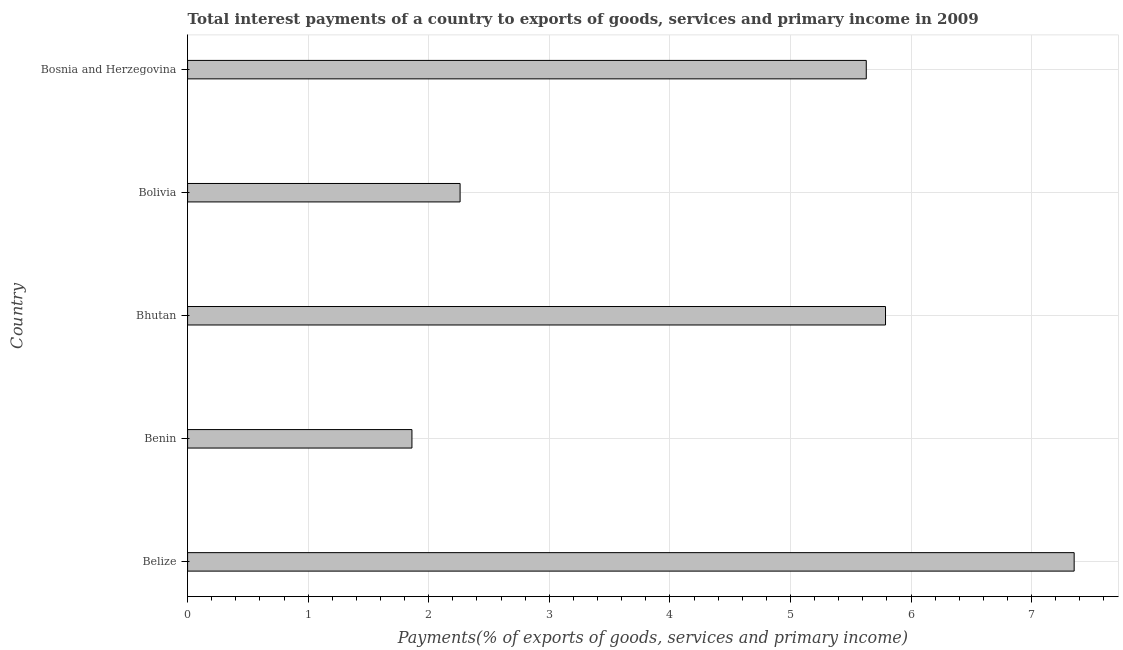Does the graph contain any zero values?
Your answer should be compact. No. Does the graph contain grids?
Give a very brief answer. Yes. What is the title of the graph?
Your answer should be very brief. Total interest payments of a country to exports of goods, services and primary income in 2009. What is the label or title of the X-axis?
Keep it short and to the point. Payments(% of exports of goods, services and primary income). What is the total interest payments on external debt in Bosnia and Herzegovina?
Offer a terse response. 5.63. Across all countries, what is the maximum total interest payments on external debt?
Make the answer very short. 7.35. Across all countries, what is the minimum total interest payments on external debt?
Provide a succinct answer. 1.86. In which country was the total interest payments on external debt maximum?
Your answer should be very brief. Belize. In which country was the total interest payments on external debt minimum?
Provide a succinct answer. Benin. What is the sum of the total interest payments on external debt?
Offer a terse response. 22.89. What is the difference between the total interest payments on external debt in Belize and Bolivia?
Ensure brevity in your answer.  5.09. What is the average total interest payments on external debt per country?
Give a very brief answer. 4.58. What is the median total interest payments on external debt?
Keep it short and to the point. 5.63. In how many countries, is the total interest payments on external debt greater than 6.6 %?
Provide a short and direct response. 1. What is the ratio of the total interest payments on external debt in Bolivia to that in Bosnia and Herzegovina?
Provide a short and direct response. 0.4. Is the total interest payments on external debt in Belize less than that in Bosnia and Herzegovina?
Provide a short and direct response. No. Is the difference between the total interest payments on external debt in Belize and Bolivia greater than the difference between any two countries?
Keep it short and to the point. No. What is the difference between the highest and the second highest total interest payments on external debt?
Provide a succinct answer. 1.56. What is the difference between the highest and the lowest total interest payments on external debt?
Provide a short and direct response. 5.49. How many countries are there in the graph?
Your answer should be very brief. 5. Are the values on the major ticks of X-axis written in scientific E-notation?
Give a very brief answer. No. What is the Payments(% of exports of goods, services and primary income) of Belize?
Your answer should be compact. 7.35. What is the Payments(% of exports of goods, services and primary income) of Benin?
Give a very brief answer. 1.86. What is the Payments(% of exports of goods, services and primary income) in Bhutan?
Keep it short and to the point. 5.79. What is the Payments(% of exports of goods, services and primary income) in Bolivia?
Your answer should be very brief. 2.26. What is the Payments(% of exports of goods, services and primary income) in Bosnia and Herzegovina?
Offer a very short reply. 5.63. What is the difference between the Payments(% of exports of goods, services and primary income) in Belize and Benin?
Provide a succinct answer. 5.49. What is the difference between the Payments(% of exports of goods, services and primary income) in Belize and Bhutan?
Offer a very short reply. 1.56. What is the difference between the Payments(% of exports of goods, services and primary income) in Belize and Bolivia?
Make the answer very short. 5.09. What is the difference between the Payments(% of exports of goods, services and primary income) in Belize and Bosnia and Herzegovina?
Give a very brief answer. 1.72. What is the difference between the Payments(% of exports of goods, services and primary income) in Benin and Bhutan?
Provide a succinct answer. -3.93. What is the difference between the Payments(% of exports of goods, services and primary income) in Benin and Bolivia?
Keep it short and to the point. -0.4. What is the difference between the Payments(% of exports of goods, services and primary income) in Benin and Bosnia and Herzegovina?
Offer a very short reply. -3.77. What is the difference between the Payments(% of exports of goods, services and primary income) in Bhutan and Bolivia?
Make the answer very short. 3.53. What is the difference between the Payments(% of exports of goods, services and primary income) in Bhutan and Bosnia and Herzegovina?
Ensure brevity in your answer.  0.16. What is the difference between the Payments(% of exports of goods, services and primary income) in Bolivia and Bosnia and Herzegovina?
Provide a short and direct response. -3.37. What is the ratio of the Payments(% of exports of goods, services and primary income) in Belize to that in Benin?
Offer a very short reply. 3.95. What is the ratio of the Payments(% of exports of goods, services and primary income) in Belize to that in Bhutan?
Keep it short and to the point. 1.27. What is the ratio of the Payments(% of exports of goods, services and primary income) in Belize to that in Bolivia?
Give a very brief answer. 3.25. What is the ratio of the Payments(% of exports of goods, services and primary income) in Belize to that in Bosnia and Herzegovina?
Give a very brief answer. 1.31. What is the ratio of the Payments(% of exports of goods, services and primary income) in Benin to that in Bhutan?
Your response must be concise. 0.32. What is the ratio of the Payments(% of exports of goods, services and primary income) in Benin to that in Bolivia?
Provide a succinct answer. 0.82. What is the ratio of the Payments(% of exports of goods, services and primary income) in Benin to that in Bosnia and Herzegovina?
Ensure brevity in your answer.  0.33. What is the ratio of the Payments(% of exports of goods, services and primary income) in Bhutan to that in Bolivia?
Your response must be concise. 2.56. What is the ratio of the Payments(% of exports of goods, services and primary income) in Bhutan to that in Bosnia and Herzegovina?
Make the answer very short. 1.03. What is the ratio of the Payments(% of exports of goods, services and primary income) in Bolivia to that in Bosnia and Herzegovina?
Provide a short and direct response. 0.4. 